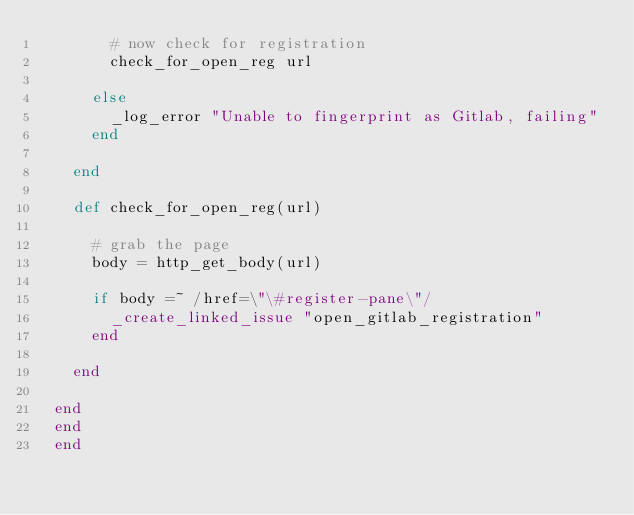Convert code to text. <code><loc_0><loc_0><loc_500><loc_500><_Ruby_>        # now check for registration
        check_for_open_reg url

      else
        _log_error "Unable to fingerprint as Gitlab, failing"
      end

    end

    def check_for_open_reg(url)

      # grab the page
      body = http_get_body(url)

      if body =~ /href=\"\#register-pane\"/
        _create_linked_issue "open_gitlab_registration"
      end

    end

  end
  end
  end
</code> 